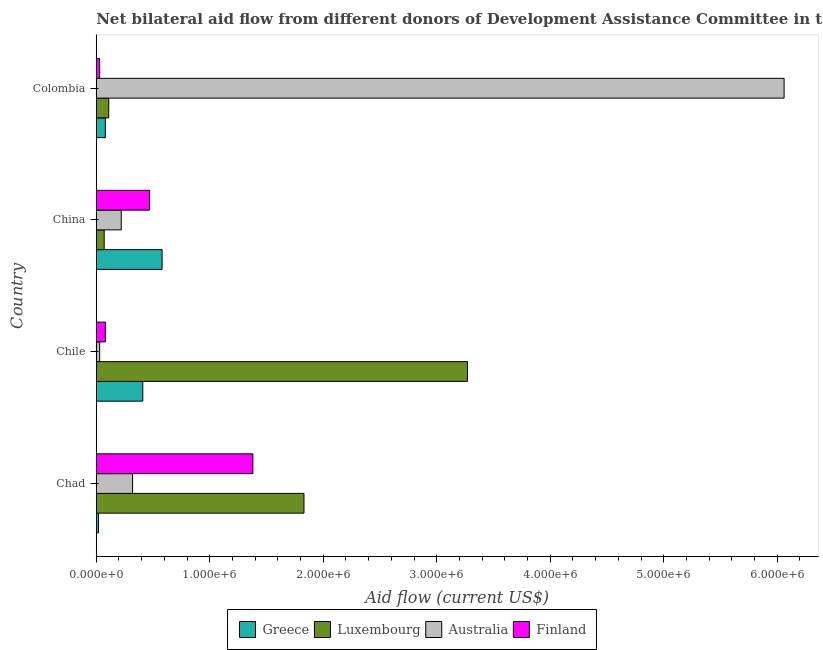How many groups of bars are there?
Your answer should be very brief. 4. Are the number of bars per tick equal to the number of legend labels?
Ensure brevity in your answer.  Yes. How many bars are there on the 1st tick from the bottom?
Offer a very short reply. 4. What is the label of the 4th group of bars from the top?
Provide a short and direct response. Chad. In how many cases, is the number of bars for a given country not equal to the number of legend labels?
Offer a very short reply. 0. What is the amount of aid given by luxembourg in Colombia?
Ensure brevity in your answer.  1.10e+05. Across all countries, what is the maximum amount of aid given by finland?
Give a very brief answer. 1.38e+06. Across all countries, what is the minimum amount of aid given by luxembourg?
Keep it short and to the point. 7.00e+04. In which country was the amount of aid given by luxembourg maximum?
Give a very brief answer. Chile. In which country was the amount of aid given by greece minimum?
Make the answer very short. Chad. What is the total amount of aid given by australia in the graph?
Make the answer very short. 6.63e+06. What is the difference between the amount of aid given by luxembourg in Chad and that in Chile?
Keep it short and to the point. -1.44e+06. What is the difference between the amount of aid given by australia in China and the amount of aid given by luxembourg in Chile?
Your answer should be very brief. -3.05e+06. What is the average amount of aid given by greece per country?
Offer a very short reply. 2.72e+05. What is the difference between the amount of aid given by luxembourg and amount of aid given by greece in Colombia?
Provide a short and direct response. 3.00e+04. What is the ratio of the amount of aid given by finland in China to that in Colombia?
Your response must be concise. 15.67. What is the difference between the highest and the second highest amount of aid given by greece?
Keep it short and to the point. 1.70e+05. What is the difference between the highest and the lowest amount of aid given by finland?
Provide a succinct answer. 1.35e+06. Is the sum of the amount of aid given by greece in Chad and Chile greater than the maximum amount of aid given by australia across all countries?
Keep it short and to the point. No. What does the 2nd bar from the top in Chile represents?
Offer a terse response. Australia. What does the 3rd bar from the bottom in Chad represents?
Ensure brevity in your answer.  Australia. How many countries are there in the graph?
Provide a succinct answer. 4. Does the graph contain any zero values?
Offer a terse response. No. How many legend labels are there?
Ensure brevity in your answer.  4. What is the title of the graph?
Give a very brief answer. Net bilateral aid flow from different donors of Development Assistance Committee in the year 2010. What is the Aid flow (current US$) of Luxembourg in Chad?
Your response must be concise. 1.83e+06. What is the Aid flow (current US$) of Finland in Chad?
Provide a succinct answer. 1.38e+06. What is the Aid flow (current US$) in Greece in Chile?
Ensure brevity in your answer.  4.10e+05. What is the Aid flow (current US$) in Luxembourg in Chile?
Your response must be concise. 3.27e+06. What is the Aid flow (current US$) of Finland in Chile?
Your answer should be compact. 8.00e+04. What is the Aid flow (current US$) in Greece in China?
Your answer should be very brief. 5.80e+05. What is the Aid flow (current US$) of Luxembourg in China?
Offer a terse response. 7.00e+04. What is the Aid flow (current US$) of Finland in China?
Provide a succinct answer. 4.70e+05. What is the Aid flow (current US$) in Australia in Colombia?
Your answer should be very brief. 6.06e+06. What is the Aid flow (current US$) of Finland in Colombia?
Your answer should be compact. 3.00e+04. Across all countries, what is the maximum Aid flow (current US$) of Greece?
Your response must be concise. 5.80e+05. Across all countries, what is the maximum Aid flow (current US$) in Luxembourg?
Provide a succinct answer. 3.27e+06. Across all countries, what is the maximum Aid flow (current US$) in Australia?
Keep it short and to the point. 6.06e+06. Across all countries, what is the maximum Aid flow (current US$) of Finland?
Give a very brief answer. 1.38e+06. Across all countries, what is the minimum Aid flow (current US$) of Luxembourg?
Give a very brief answer. 7.00e+04. Across all countries, what is the minimum Aid flow (current US$) of Australia?
Offer a terse response. 3.00e+04. Across all countries, what is the minimum Aid flow (current US$) in Finland?
Give a very brief answer. 3.00e+04. What is the total Aid flow (current US$) of Greece in the graph?
Keep it short and to the point. 1.09e+06. What is the total Aid flow (current US$) of Luxembourg in the graph?
Ensure brevity in your answer.  5.28e+06. What is the total Aid flow (current US$) of Australia in the graph?
Ensure brevity in your answer.  6.63e+06. What is the total Aid flow (current US$) of Finland in the graph?
Your answer should be very brief. 1.96e+06. What is the difference between the Aid flow (current US$) in Greece in Chad and that in Chile?
Ensure brevity in your answer.  -3.90e+05. What is the difference between the Aid flow (current US$) in Luxembourg in Chad and that in Chile?
Offer a terse response. -1.44e+06. What is the difference between the Aid flow (current US$) in Australia in Chad and that in Chile?
Your response must be concise. 2.90e+05. What is the difference between the Aid flow (current US$) in Finland in Chad and that in Chile?
Give a very brief answer. 1.30e+06. What is the difference between the Aid flow (current US$) in Greece in Chad and that in China?
Provide a short and direct response. -5.60e+05. What is the difference between the Aid flow (current US$) of Luxembourg in Chad and that in China?
Offer a very short reply. 1.76e+06. What is the difference between the Aid flow (current US$) of Australia in Chad and that in China?
Ensure brevity in your answer.  1.00e+05. What is the difference between the Aid flow (current US$) in Finland in Chad and that in China?
Your response must be concise. 9.10e+05. What is the difference between the Aid flow (current US$) in Luxembourg in Chad and that in Colombia?
Ensure brevity in your answer.  1.72e+06. What is the difference between the Aid flow (current US$) of Australia in Chad and that in Colombia?
Keep it short and to the point. -5.74e+06. What is the difference between the Aid flow (current US$) of Finland in Chad and that in Colombia?
Offer a very short reply. 1.35e+06. What is the difference between the Aid flow (current US$) of Greece in Chile and that in China?
Offer a terse response. -1.70e+05. What is the difference between the Aid flow (current US$) of Luxembourg in Chile and that in China?
Your response must be concise. 3.20e+06. What is the difference between the Aid flow (current US$) in Finland in Chile and that in China?
Your answer should be compact. -3.90e+05. What is the difference between the Aid flow (current US$) of Greece in Chile and that in Colombia?
Provide a succinct answer. 3.30e+05. What is the difference between the Aid flow (current US$) in Luxembourg in Chile and that in Colombia?
Provide a short and direct response. 3.16e+06. What is the difference between the Aid flow (current US$) of Australia in Chile and that in Colombia?
Make the answer very short. -6.03e+06. What is the difference between the Aid flow (current US$) in Australia in China and that in Colombia?
Your answer should be very brief. -5.84e+06. What is the difference between the Aid flow (current US$) in Finland in China and that in Colombia?
Make the answer very short. 4.40e+05. What is the difference between the Aid flow (current US$) of Greece in Chad and the Aid flow (current US$) of Luxembourg in Chile?
Offer a very short reply. -3.25e+06. What is the difference between the Aid flow (current US$) of Greece in Chad and the Aid flow (current US$) of Finland in Chile?
Offer a very short reply. -6.00e+04. What is the difference between the Aid flow (current US$) in Luxembourg in Chad and the Aid flow (current US$) in Australia in Chile?
Your answer should be very brief. 1.80e+06. What is the difference between the Aid flow (current US$) of Luxembourg in Chad and the Aid flow (current US$) of Finland in Chile?
Your answer should be very brief. 1.75e+06. What is the difference between the Aid flow (current US$) of Australia in Chad and the Aid flow (current US$) of Finland in Chile?
Your response must be concise. 2.40e+05. What is the difference between the Aid flow (current US$) of Greece in Chad and the Aid flow (current US$) of Luxembourg in China?
Keep it short and to the point. -5.00e+04. What is the difference between the Aid flow (current US$) of Greece in Chad and the Aid flow (current US$) of Australia in China?
Offer a very short reply. -2.00e+05. What is the difference between the Aid flow (current US$) of Greece in Chad and the Aid flow (current US$) of Finland in China?
Keep it short and to the point. -4.50e+05. What is the difference between the Aid flow (current US$) of Luxembourg in Chad and the Aid flow (current US$) of Australia in China?
Ensure brevity in your answer.  1.61e+06. What is the difference between the Aid flow (current US$) of Luxembourg in Chad and the Aid flow (current US$) of Finland in China?
Your answer should be compact. 1.36e+06. What is the difference between the Aid flow (current US$) of Australia in Chad and the Aid flow (current US$) of Finland in China?
Make the answer very short. -1.50e+05. What is the difference between the Aid flow (current US$) of Greece in Chad and the Aid flow (current US$) of Australia in Colombia?
Your answer should be compact. -6.04e+06. What is the difference between the Aid flow (current US$) of Greece in Chad and the Aid flow (current US$) of Finland in Colombia?
Provide a short and direct response. -10000. What is the difference between the Aid flow (current US$) of Luxembourg in Chad and the Aid flow (current US$) of Australia in Colombia?
Offer a very short reply. -4.23e+06. What is the difference between the Aid flow (current US$) in Luxembourg in Chad and the Aid flow (current US$) in Finland in Colombia?
Ensure brevity in your answer.  1.80e+06. What is the difference between the Aid flow (current US$) of Australia in Chad and the Aid flow (current US$) of Finland in Colombia?
Ensure brevity in your answer.  2.90e+05. What is the difference between the Aid flow (current US$) in Greece in Chile and the Aid flow (current US$) in Finland in China?
Keep it short and to the point. -6.00e+04. What is the difference between the Aid flow (current US$) of Luxembourg in Chile and the Aid flow (current US$) of Australia in China?
Your response must be concise. 3.05e+06. What is the difference between the Aid flow (current US$) in Luxembourg in Chile and the Aid flow (current US$) in Finland in China?
Offer a terse response. 2.80e+06. What is the difference between the Aid flow (current US$) in Australia in Chile and the Aid flow (current US$) in Finland in China?
Make the answer very short. -4.40e+05. What is the difference between the Aid flow (current US$) of Greece in Chile and the Aid flow (current US$) of Luxembourg in Colombia?
Offer a very short reply. 3.00e+05. What is the difference between the Aid flow (current US$) in Greece in Chile and the Aid flow (current US$) in Australia in Colombia?
Keep it short and to the point. -5.65e+06. What is the difference between the Aid flow (current US$) of Greece in Chile and the Aid flow (current US$) of Finland in Colombia?
Provide a short and direct response. 3.80e+05. What is the difference between the Aid flow (current US$) in Luxembourg in Chile and the Aid flow (current US$) in Australia in Colombia?
Make the answer very short. -2.79e+06. What is the difference between the Aid flow (current US$) of Luxembourg in Chile and the Aid flow (current US$) of Finland in Colombia?
Offer a very short reply. 3.24e+06. What is the difference between the Aid flow (current US$) of Greece in China and the Aid flow (current US$) of Australia in Colombia?
Ensure brevity in your answer.  -5.48e+06. What is the difference between the Aid flow (current US$) of Luxembourg in China and the Aid flow (current US$) of Australia in Colombia?
Provide a short and direct response. -5.99e+06. What is the difference between the Aid flow (current US$) in Luxembourg in China and the Aid flow (current US$) in Finland in Colombia?
Your answer should be very brief. 4.00e+04. What is the average Aid flow (current US$) of Greece per country?
Offer a terse response. 2.72e+05. What is the average Aid flow (current US$) of Luxembourg per country?
Your answer should be compact. 1.32e+06. What is the average Aid flow (current US$) of Australia per country?
Make the answer very short. 1.66e+06. What is the difference between the Aid flow (current US$) in Greece and Aid flow (current US$) in Luxembourg in Chad?
Give a very brief answer. -1.81e+06. What is the difference between the Aid flow (current US$) of Greece and Aid flow (current US$) of Finland in Chad?
Give a very brief answer. -1.36e+06. What is the difference between the Aid flow (current US$) of Luxembourg and Aid flow (current US$) of Australia in Chad?
Give a very brief answer. 1.51e+06. What is the difference between the Aid flow (current US$) of Australia and Aid flow (current US$) of Finland in Chad?
Give a very brief answer. -1.06e+06. What is the difference between the Aid flow (current US$) of Greece and Aid flow (current US$) of Luxembourg in Chile?
Keep it short and to the point. -2.86e+06. What is the difference between the Aid flow (current US$) of Greece and Aid flow (current US$) of Australia in Chile?
Keep it short and to the point. 3.80e+05. What is the difference between the Aid flow (current US$) in Luxembourg and Aid flow (current US$) in Australia in Chile?
Keep it short and to the point. 3.24e+06. What is the difference between the Aid flow (current US$) of Luxembourg and Aid flow (current US$) of Finland in Chile?
Keep it short and to the point. 3.19e+06. What is the difference between the Aid flow (current US$) of Greece and Aid flow (current US$) of Luxembourg in China?
Provide a short and direct response. 5.10e+05. What is the difference between the Aid flow (current US$) of Greece and Aid flow (current US$) of Finland in China?
Provide a succinct answer. 1.10e+05. What is the difference between the Aid flow (current US$) of Luxembourg and Aid flow (current US$) of Australia in China?
Provide a succinct answer. -1.50e+05. What is the difference between the Aid flow (current US$) in Luxembourg and Aid flow (current US$) in Finland in China?
Provide a short and direct response. -4.00e+05. What is the difference between the Aid flow (current US$) of Greece and Aid flow (current US$) of Luxembourg in Colombia?
Offer a very short reply. -3.00e+04. What is the difference between the Aid flow (current US$) of Greece and Aid flow (current US$) of Australia in Colombia?
Provide a short and direct response. -5.98e+06. What is the difference between the Aid flow (current US$) of Luxembourg and Aid flow (current US$) of Australia in Colombia?
Your answer should be compact. -5.95e+06. What is the difference between the Aid flow (current US$) in Luxembourg and Aid flow (current US$) in Finland in Colombia?
Offer a very short reply. 8.00e+04. What is the difference between the Aid flow (current US$) of Australia and Aid flow (current US$) of Finland in Colombia?
Make the answer very short. 6.03e+06. What is the ratio of the Aid flow (current US$) of Greece in Chad to that in Chile?
Make the answer very short. 0.05. What is the ratio of the Aid flow (current US$) in Luxembourg in Chad to that in Chile?
Keep it short and to the point. 0.56. What is the ratio of the Aid flow (current US$) in Australia in Chad to that in Chile?
Make the answer very short. 10.67. What is the ratio of the Aid flow (current US$) in Finland in Chad to that in Chile?
Provide a short and direct response. 17.25. What is the ratio of the Aid flow (current US$) in Greece in Chad to that in China?
Ensure brevity in your answer.  0.03. What is the ratio of the Aid flow (current US$) of Luxembourg in Chad to that in China?
Offer a very short reply. 26.14. What is the ratio of the Aid flow (current US$) in Australia in Chad to that in China?
Provide a short and direct response. 1.45. What is the ratio of the Aid flow (current US$) of Finland in Chad to that in China?
Ensure brevity in your answer.  2.94. What is the ratio of the Aid flow (current US$) in Luxembourg in Chad to that in Colombia?
Keep it short and to the point. 16.64. What is the ratio of the Aid flow (current US$) in Australia in Chad to that in Colombia?
Give a very brief answer. 0.05. What is the ratio of the Aid flow (current US$) of Finland in Chad to that in Colombia?
Your response must be concise. 46. What is the ratio of the Aid flow (current US$) of Greece in Chile to that in China?
Offer a terse response. 0.71. What is the ratio of the Aid flow (current US$) in Luxembourg in Chile to that in China?
Your answer should be very brief. 46.71. What is the ratio of the Aid flow (current US$) in Australia in Chile to that in China?
Ensure brevity in your answer.  0.14. What is the ratio of the Aid flow (current US$) of Finland in Chile to that in China?
Keep it short and to the point. 0.17. What is the ratio of the Aid flow (current US$) in Greece in Chile to that in Colombia?
Keep it short and to the point. 5.12. What is the ratio of the Aid flow (current US$) in Luxembourg in Chile to that in Colombia?
Ensure brevity in your answer.  29.73. What is the ratio of the Aid flow (current US$) of Australia in Chile to that in Colombia?
Your response must be concise. 0.01. What is the ratio of the Aid flow (current US$) of Finland in Chile to that in Colombia?
Your answer should be very brief. 2.67. What is the ratio of the Aid flow (current US$) of Greece in China to that in Colombia?
Offer a terse response. 7.25. What is the ratio of the Aid flow (current US$) of Luxembourg in China to that in Colombia?
Keep it short and to the point. 0.64. What is the ratio of the Aid flow (current US$) of Australia in China to that in Colombia?
Your response must be concise. 0.04. What is the ratio of the Aid flow (current US$) of Finland in China to that in Colombia?
Your answer should be very brief. 15.67. What is the difference between the highest and the second highest Aid flow (current US$) in Luxembourg?
Offer a terse response. 1.44e+06. What is the difference between the highest and the second highest Aid flow (current US$) in Australia?
Provide a short and direct response. 5.74e+06. What is the difference between the highest and the second highest Aid flow (current US$) in Finland?
Give a very brief answer. 9.10e+05. What is the difference between the highest and the lowest Aid flow (current US$) of Greece?
Provide a short and direct response. 5.60e+05. What is the difference between the highest and the lowest Aid flow (current US$) of Luxembourg?
Your answer should be very brief. 3.20e+06. What is the difference between the highest and the lowest Aid flow (current US$) of Australia?
Your response must be concise. 6.03e+06. What is the difference between the highest and the lowest Aid flow (current US$) of Finland?
Your answer should be compact. 1.35e+06. 